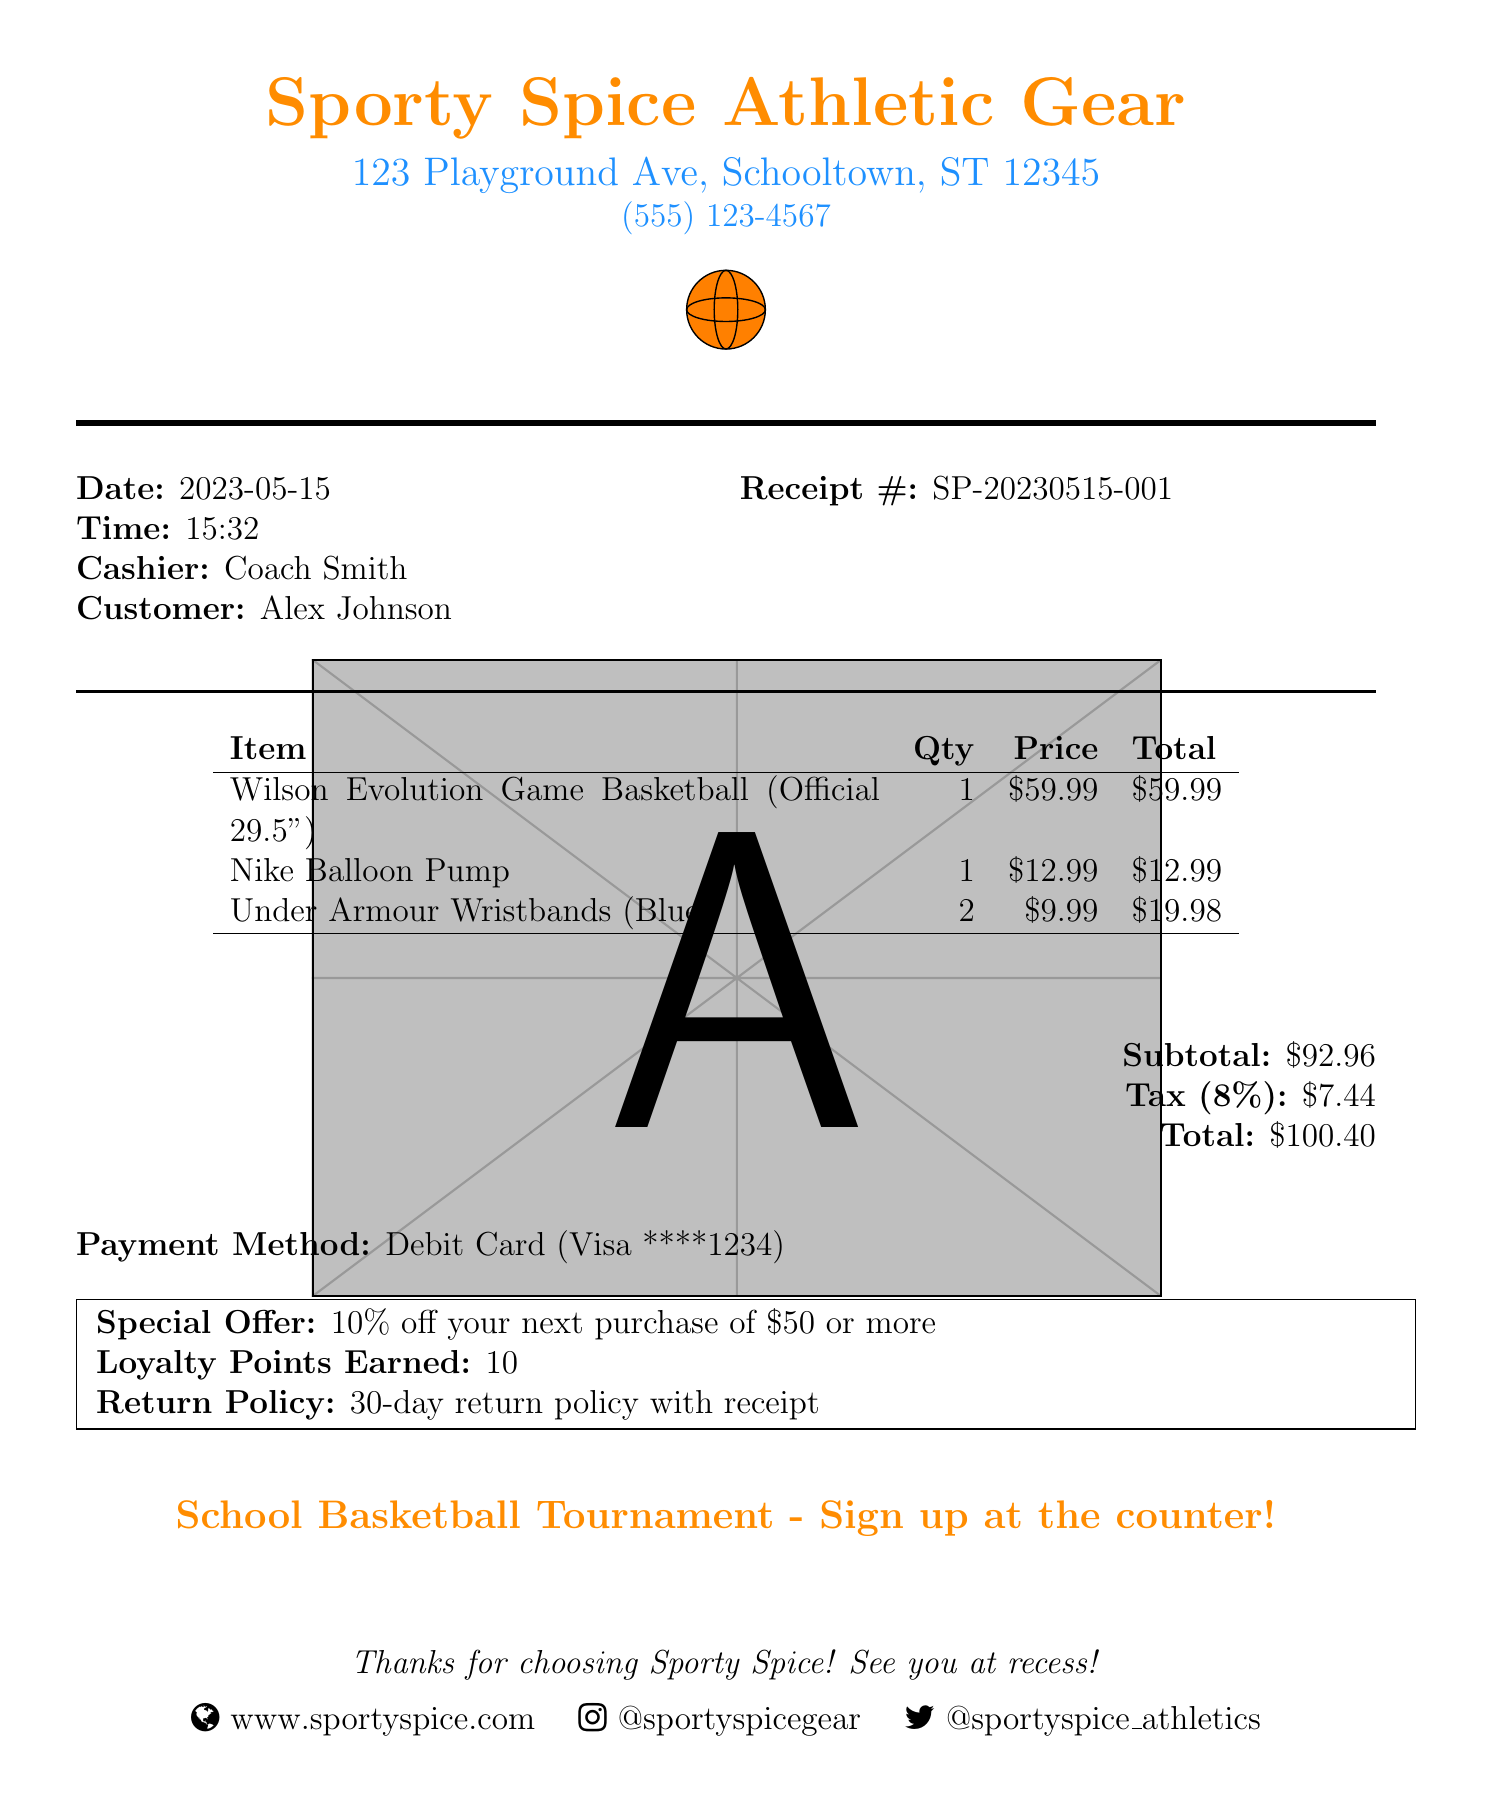what is the store name? The store name is listed at the top of the receipt.
Answer: Sporty Spice Athletic Gear what is the item quantity for the wristbands? The quantity for the Under Armour Wristbands is shown in the item list.
Answer: 2 what is the date of the purchase? The date of the purchase is provided near the top of the receipt.
Answer: 2023-05-15 who is the cashier? The cashier's name is specified in the receipt details.
Answer: Coach Smith what is the total amount spent? The total amount is calculated and displayed at the end of the receipt.
Answer: $100.40 what percentage is the tax rate? The tax rate is explicitly mentioned in the receipt, specifically for tax calculations.
Answer: 8% how many loyalty points were earned? The number of loyalty points earned is summarized in the special offer section.
Answer: 10 what is the special offer? The special offer is clearly mentioned as a promotional detail in the receipt.
Answer: 10% off your next purchase of $50 or more what is the return policy duration? The return policy is included in the special conditions mentioned in the receipt.
Answer: 30-day return policy with receipt 